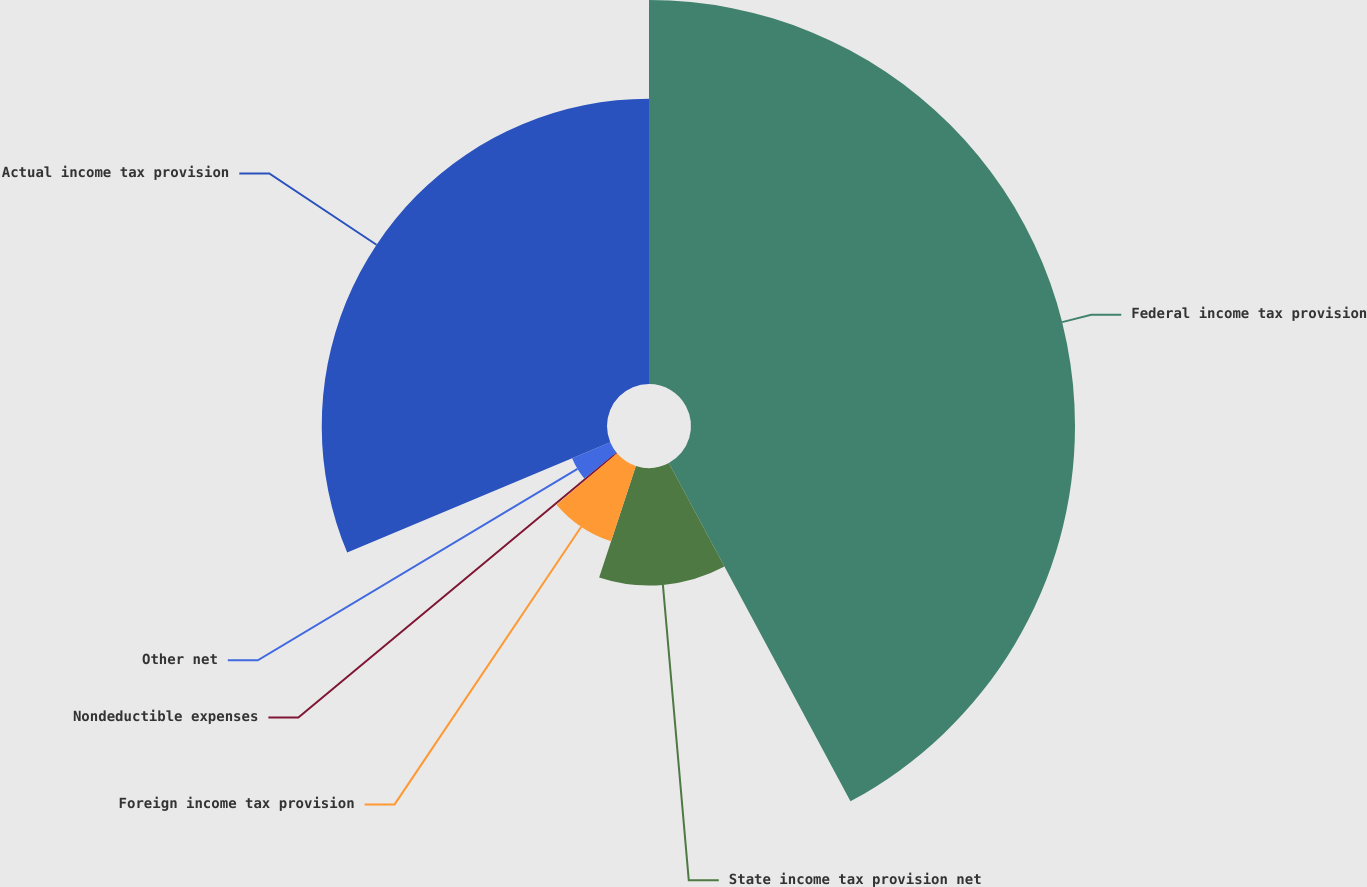Convert chart to OTSL. <chart><loc_0><loc_0><loc_500><loc_500><pie_chart><fcel>Federal income tax provision<fcel>State income tax provision net<fcel>Foreign income tax provision<fcel>Nondeductible expenses<fcel>Other net<fcel>Actual income tax provision<nl><fcel>42.16%<fcel>12.9%<fcel>8.72%<fcel>0.36%<fcel>4.54%<fcel>31.32%<nl></chart> 